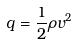<formula> <loc_0><loc_0><loc_500><loc_500>q = \frac { 1 } { 2 } \rho v ^ { 2 }</formula> 